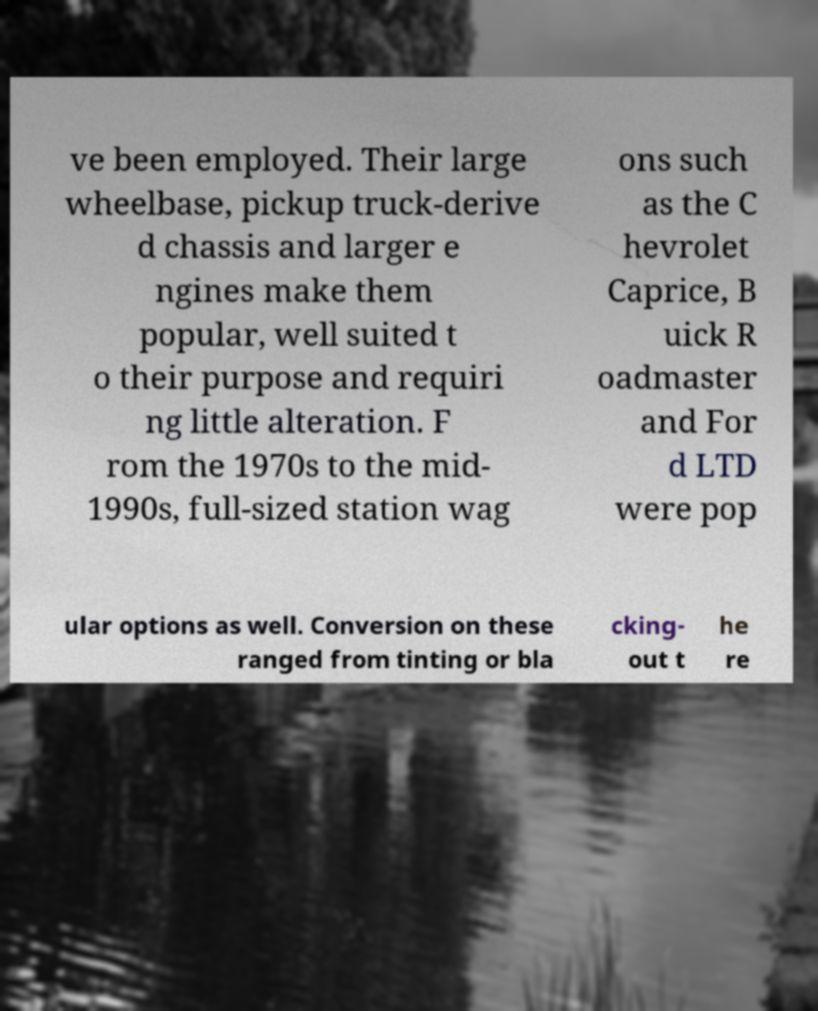Could you assist in decoding the text presented in this image and type it out clearly? ve been employed. Their large wheelbase, pickup truck-derive d chassis and larger e ngines make them popular, well suited t o their purpose and requiri ng little alteration. F rom the 1970s to the mid- 1990s, full-sized station wag ons such as the C hevrolet Caprice, B uick R oadmaster and For d LTD were pop ular options as well. Conversion on these ranged from tinting or bla cking- out t he re 